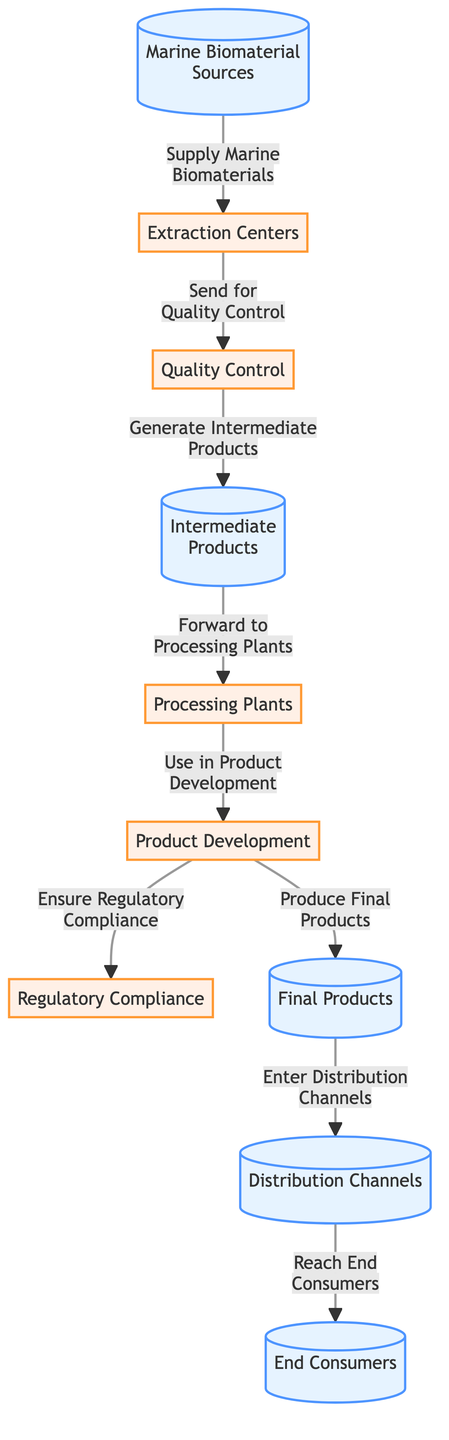What are examples of marine biomaterial sources? The node "Marine Biomaterial Sources" lists examples like "Seaweed Farms," "Shellfish Industries," and "Deep-Sea Sponge Harvesting."
Answer: Seaweed Farms, Shellfish Industries, Deep-Sea Sponge Harvesting How many processes are depicted in the diagram? The diagram includes six process nodes: "Extraction Centers," "Quality Control," "Processing Plants," "Product Development," "Regulatory Compliance," and "Quality Control." Thus, the total number is six.
Answer: 6 What is the first process in the supply chain? After examining the flow, the first process node that the flow leads to from "Marine Biomaterial Sources" is "Extraction Centers."
Answer: Extraction Centers What testing standards are used during Quality Control? The "Quality Control" node lists the testing standards as "ISO 9001" and "BSI PAS 110." These are the specific standards indicated in the attributes.
Answer: ISO 9001, BSI PAS 110 What is the function of the "Processing Plants" node? The "Processing Plants" node's purpose is indicated in the edge connecting it to the "Product Development" process, stating it is involved in "Use in Product Development."
Answer: Use in Product Development How do final products reach end consumers? The final products are forwarded to "Distribution Channels," where they enter and eventually reach "End Consumers" as per the flow connections in the diagram.
Answer: Distribution Channels What type of consumers are targeted at the end of the supply chain? The node titled "End Consumers" specifies examples, which include "Health-Conscious Individuals" and "Eco-Friendly Consumers."
Answer: Health-Conscious Individuals, Eco-Friendly Consumers Which two nodes are connected by the edge labeled "Send for Quality Control"? The edge labeled "Send for Quality Control" connects the "Extraction Centers" process node to the "Quality Control" process node as outlined in the diagram.
Answer: Extraction Centers, Quality Control How many final products are illustrated in the diagram? The "Final Products" node contains examples such as "Biodegradable Packaging," "Marine-Based Dietary Supplements," and "Natural Cosmetics," thus indicating that there are three examples provided.
Answer: 3 